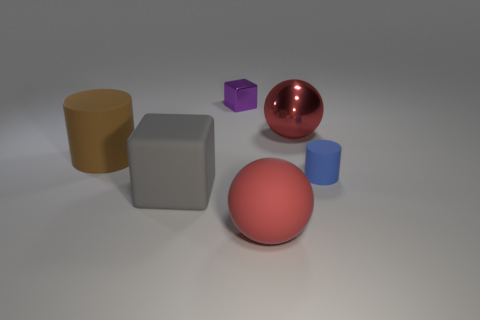Are there any other big matte cubes of the same color as the large matte block?
Keep it short and to the point. No. There is a sphere that is the same material as the brown thing; what size is it?
Offer a terse response. Large. The matte sphere that is the same color as the shiny sphere is what size?
Keep it short and to the point. Large. How many other objects are the same size as the blue rubber thing?
Provide a succinct answer. 1. What material is the cylinder that is left of the gray block?
Make the answer very short. Rubber. What shape is the large red object that is right of the big thing that is in front of the cube that is in front of the tiny cylinder?
Your answer should be compact. Sphere. Does the red matte object have the same size as the blue cylinder?
Your answer should be very brief. No. How many objects are either brown cylinders or blocks in front of the blue matte object?
Provide a succinct answer. 2. What number of things are either things that are in front of the purple shiny cube or objects on the left side of the shiny cube?
Provide a short and direct response. 5. There is a big block; are there any matte cubes behind it?
Your answer should be very brief. No. 